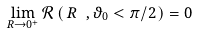<formula> <loc_0><loc_0><loc_500><loc_500>\lim _ { R \to 0 ^ { + } } \mathcal { R } \left ( \, R \ , \vartheta _ { 0 } < \pi / 2 \, \right ) = 0</formula> 